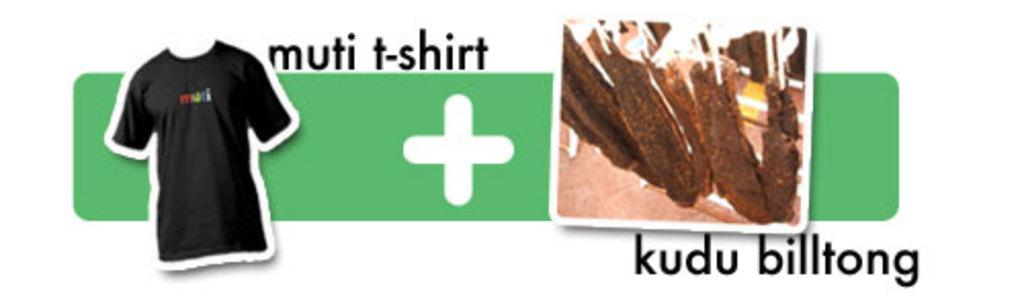<image>
Render a clear and concise summary of the photo. Logo which has a black t-shirt and the words multi t-shirt. 